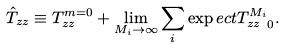<formula> <loc_0><loc_0><loc_500><loc_500>\hat { T } _ { z z } \equiv T _ { z z } ^ { m = 0 } + \lim _ { M _ { i } \to \infty } \sum _ { i } \exp e c t { T _ { z z } ^ { M _ { i } } } _ { 0 } .</formula> 